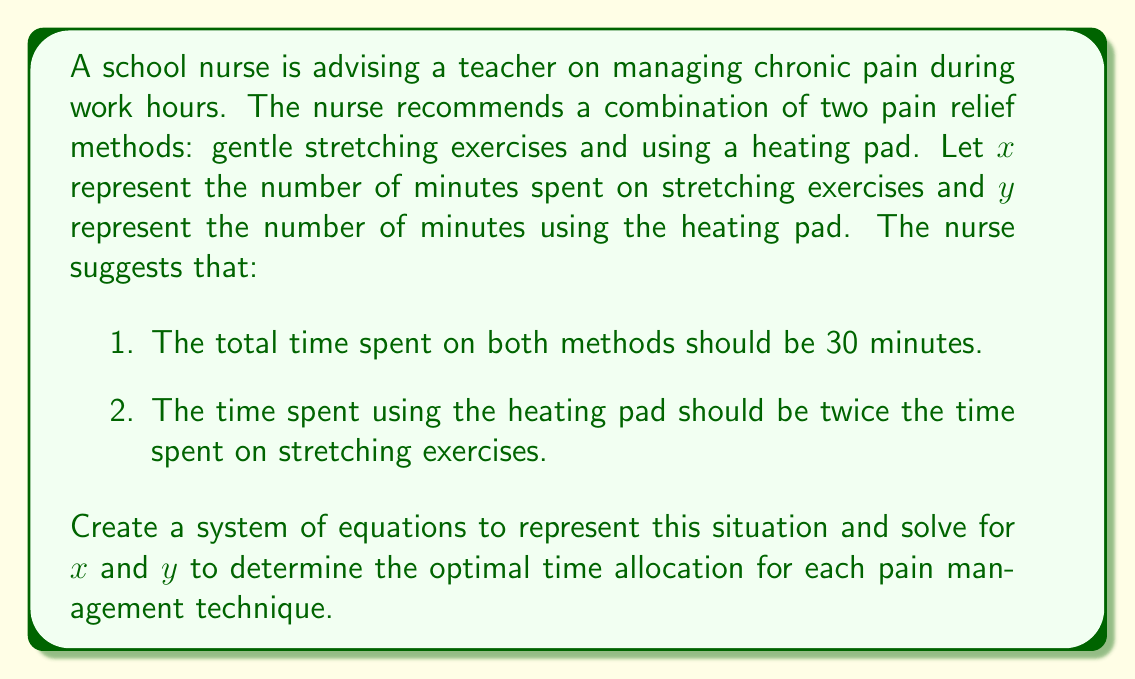Can you answer this question? Let's approach this step-by-step:

1) First, we need to translate the given information into equations:

   Equation 1: Total time = 30 minutes
   $$x + y = 30$$

   Equation 2: Heating pad time = 2 × Stretching time
   $$y = 2x$$

2) Now we have a system of two equations with two unknowns:

   $$\begin{cases}
   x + y = 30 \\
   y = 2x
   \end{cases}$$

3) We can solve this system by substitution. Let's substitute the second equation into the first:

   $$x + 2x = 30$$

4) Simplify:

   $$3x = 30$$

5) Solve for $x$:

   $$x = 10$$

6) Now that we know $x$, we can find $y$ using either of the original equations. Let's use the second equation:

   $$y = 2x = 2(10) = 20$$

7) Therefore, the optimal time allocation is:
   - Stretching exercises ($x$): 10 minutes
   - Heating pad ($y$): 20 minutes

We can verify this solution satisfies both original equations:
   10 + 20 = 30 (first equation)
   20 = 2(10) (second equation)
Answer: $x = 10, y = 20$ 